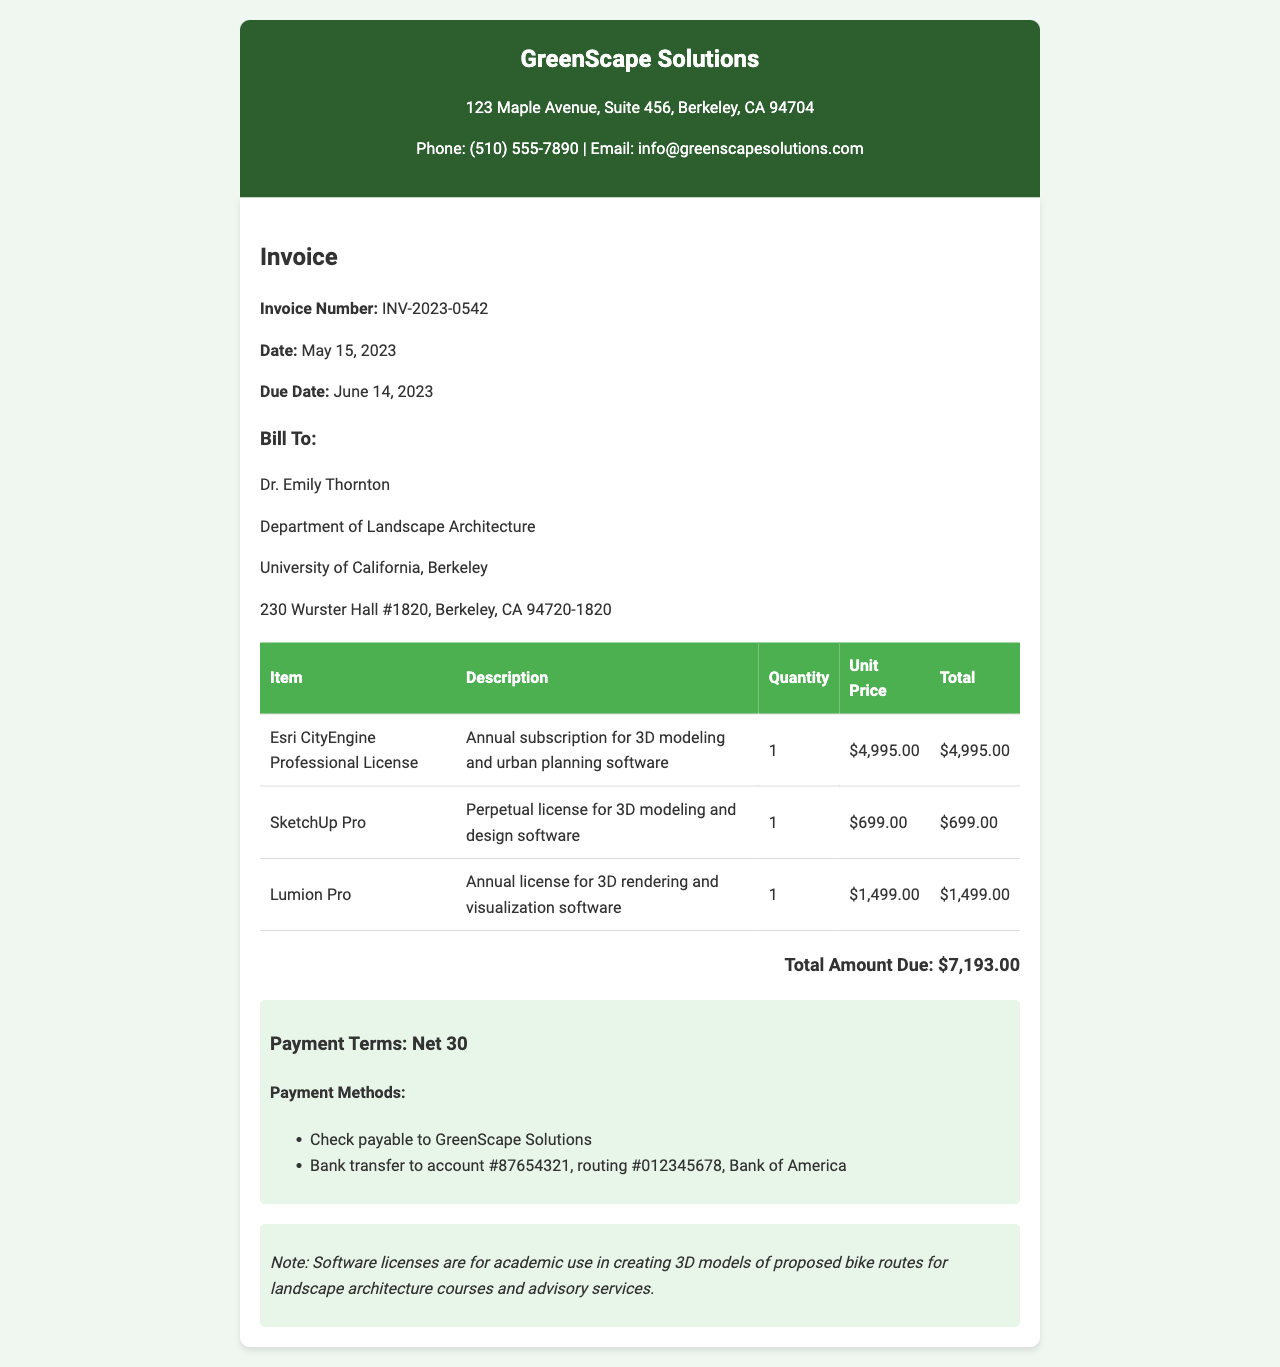What is the invoice number? The invoice number is listed under the invoice details section.
Answer: INV-2023-0542 What is the total amount due? The total amount due is mentioned at the end of the invoice.
Answer: $7,193.00 Who is the invoice billed to? The recipient of the invoice is specified under the "Bill To" section.
Answer: Dr. Emily Thornton What is the due date for payment? The due date is provided in the invoice details section.
Answer: June 14, 2023 How many software licenses are included in the invoice? The document lists three different software licenses.
Answer: 3 What is the quantity of the Esri CityEngine Professional License? The quantity for the Esri CityEngine is found in the table of items.
Answer: 1 What is the payment term specified? The payment term is indicated in the payment information section.
Answer: Net 30 What is the name of the first software item listed? The first item in the table provides the name of the software.
Answer: Esri CityEngine Professional License What type of invoice is this? The context and structure indicate that it is an invoice for software.
Answer: Invoice for software licenses 